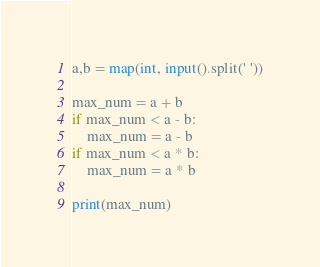Convert code to text. <code><loc_0><loc_0><loc_500><loc_500><_Python_>a,b = map(int, input().split(' '))

max_num = a + b
if max_num < a - b:
    max_num = a - b
if max_num < a * b:
    max_num = a * b

print(max_num)
</code> 